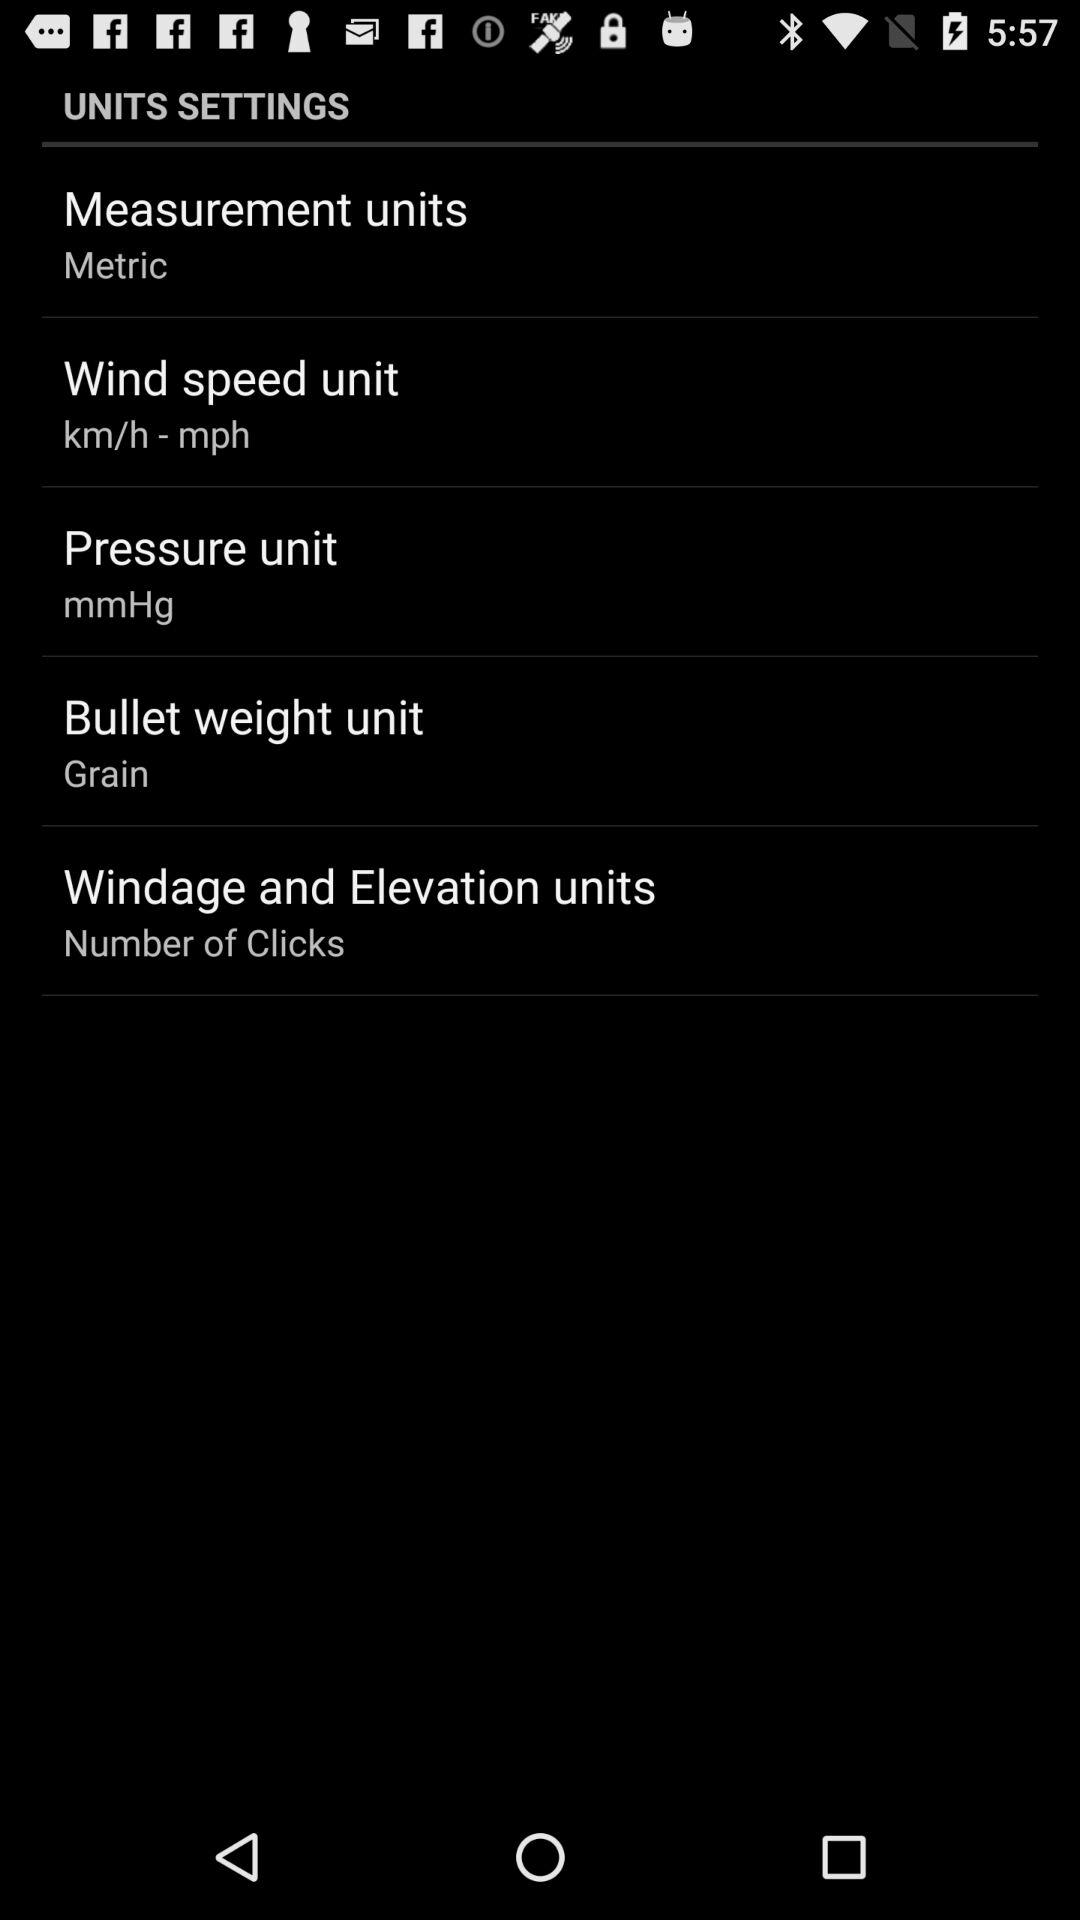In what unit is wind speed measured? The wind speed is measured in "km/h - mph". 